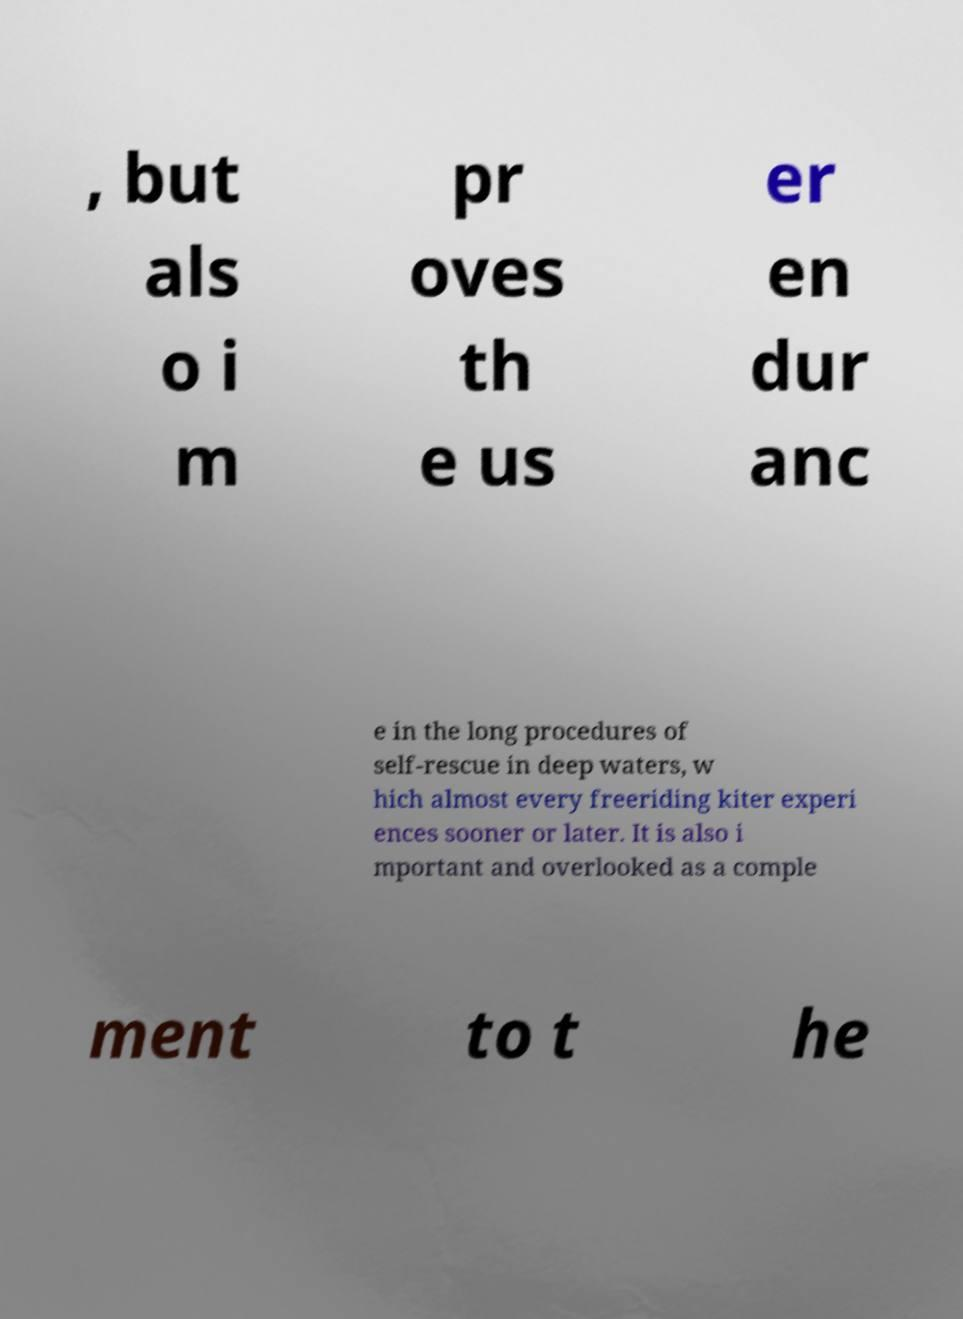Could you extract and type out the text from this image? , but als o i m pr oves th e us er en dur anc e in the long procedures of self-rescue in deep waters, w hich almost every freeriding kiter experi ences sooner or later. It is also i mportant and overlooked as a comple ment to t he 